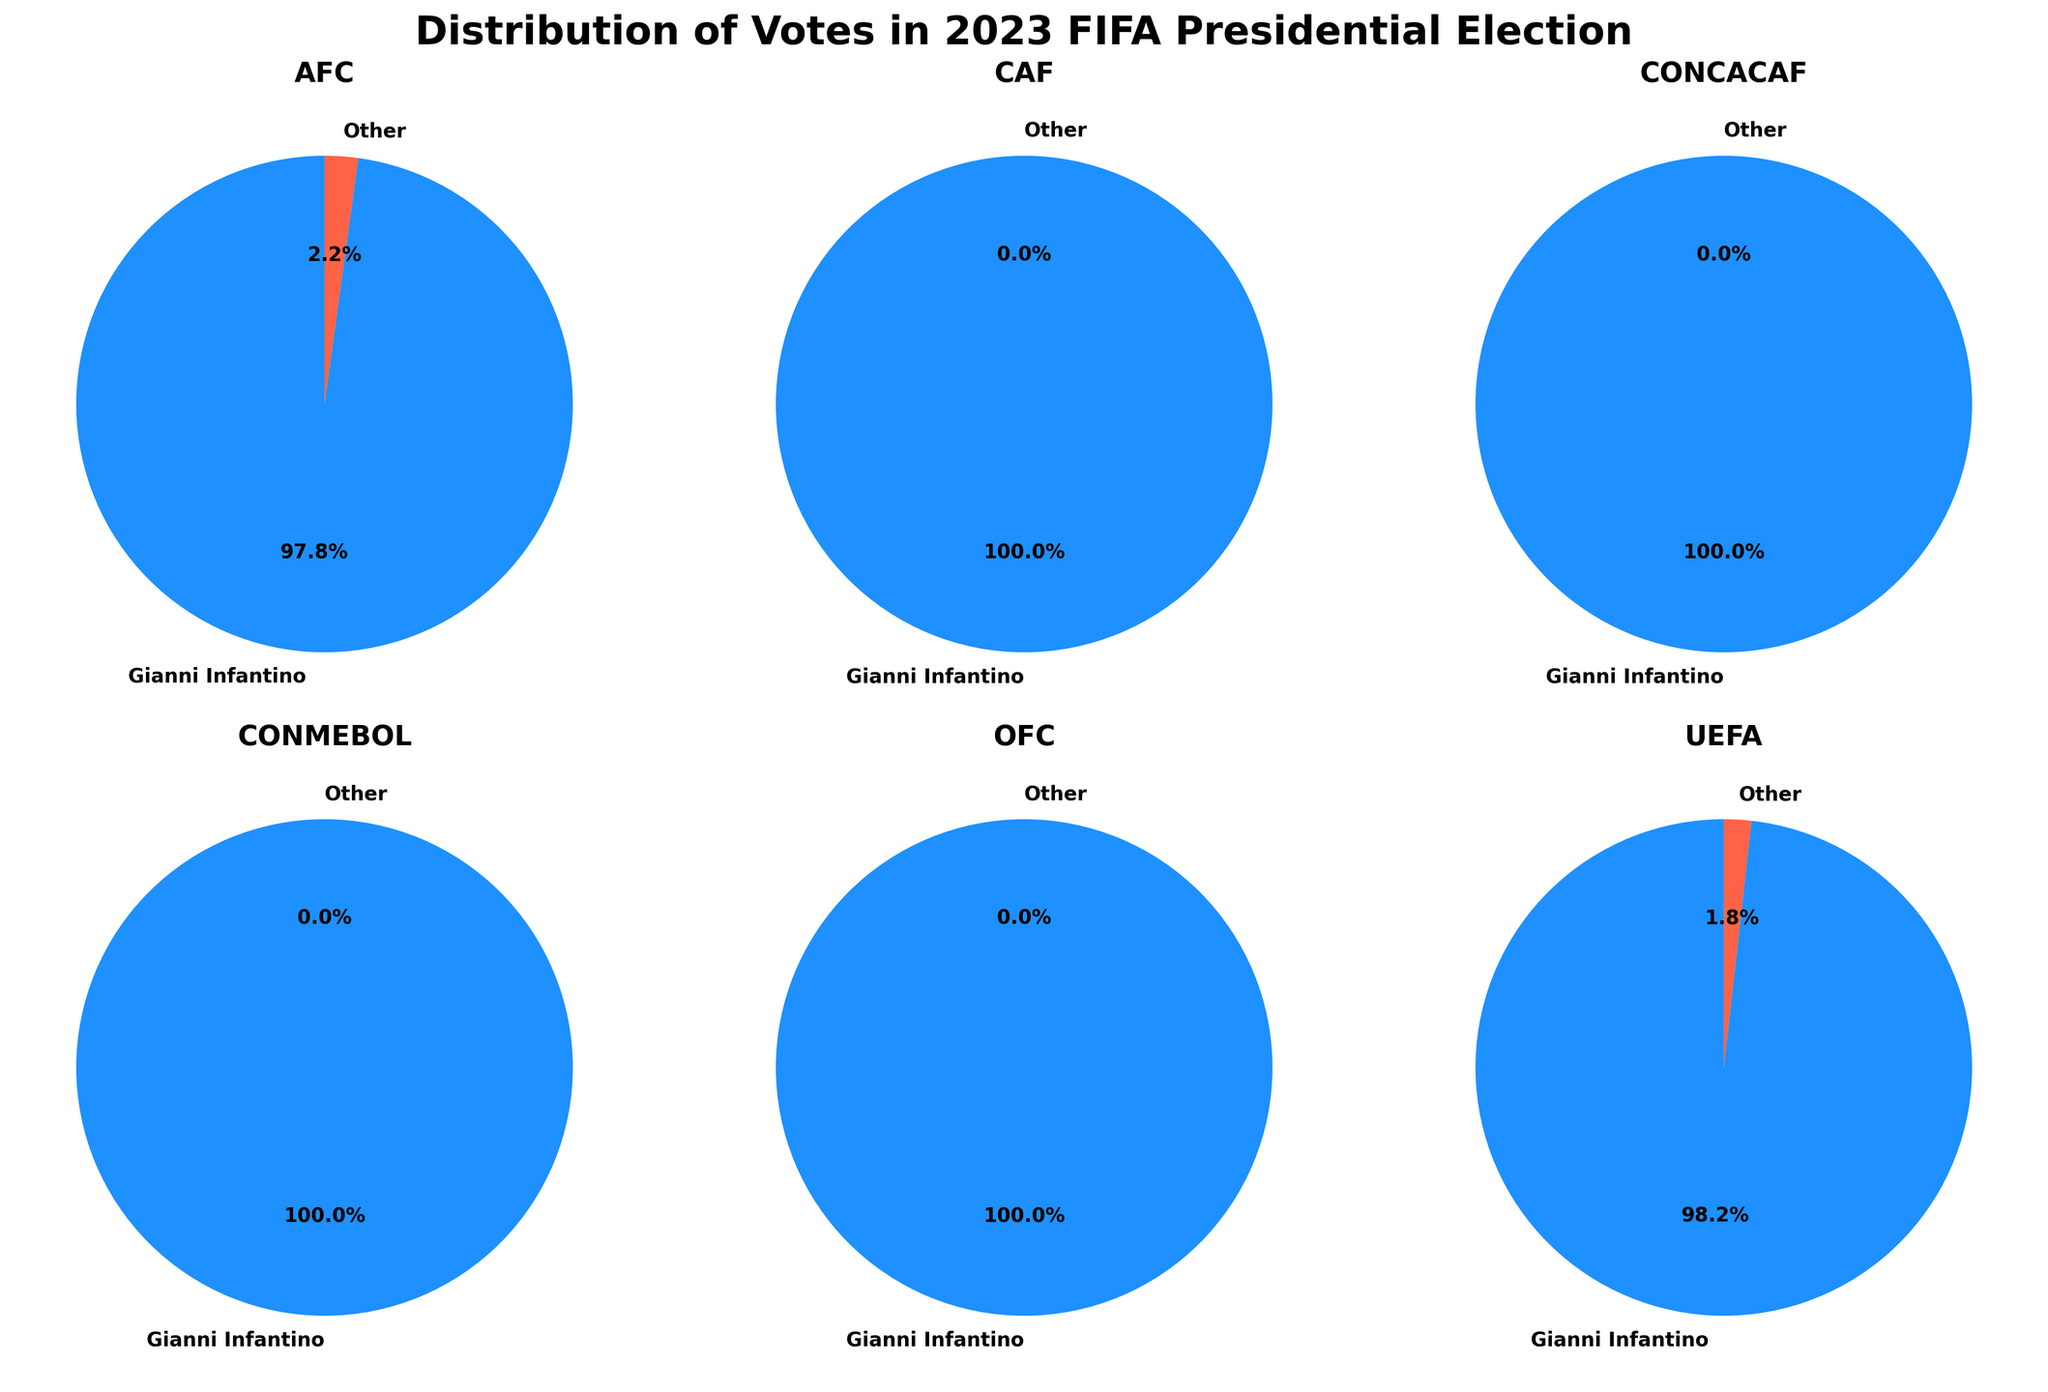Which confederation had the highest percentage of votes for candidates other than Gianni Infantino? By analyzing the pie charts, we see small segments representing votes for other candidates. Compare the percentages in these segments to find that AFC and UEFA each have a small portion for Other. AFC has 1 out of 46 total votes, and UEFA has 1 out of 56 total votes. The percentage for AFC is \( \frac{1}{46} \times 100 \approx 2.2\% \), and for UEFA it is \( \frac{1}{56} \times 100 \approx 1.8\% \). Therefore, AFC has the highest percentage for candidates other than Gianni Infantino.
Answer: AFC How many confederations had 100% of their votes for Gianni Infantino? By inspecting each pie chart, count the confederations where all votes are for Gianni Infantino. From the pie charts, CAF, CONCACAF, CONMEBOL, and OFC have only one segment, which indicates 100% of votes went to Gianni Infantino. Therefore, the number of confederations with 100% votes for Infantino is 4.
Answer: 4 Which confederation had the smallest total number of votes and how many votes were there? By looking at the total number of votes in each pie chart segment, find the confederation with the smallest value. CONMEBOL has the smallest total with 10 votes, as indicated in its respective pie chart.
Answer: CONMEBOL, 10 What is the total number of votes cast for Gianni Infantino across all confederations? To find the total votes for Gianni Infantino, sum up his votes from all the pie charts. The votes are AFC: 45, CAF: 54, CONCACAF: 35, CONMEBOL: 10, OFC: 11, UEFA: 55. Adding these together: 45 + 54 + 35 + 10 + 11 + 55 = 210.
Answer: 210 Which confederation had the highest number of votes for Gianni Infantino and how many votes were there? Observing each pie chart, compare the number of votes for Gianni Infantino. UEFA has the highest number with 55 votes, as indicated in its respective pie chart.
Answer: UEFA, 55 Calculate the average number of votes per confederation cast for candidates other than Gianni Infantino. First, identify the votes for candidates other than Gianni Infantino from each pie chart: AFC: 1, CAF: 0, CONCACAF: 0, CONMEBOL: 0, OFC: 0, UEFA: 1. Sum these values: 1 + 0 + 0 + 0 + 0 + 1 = 2. Now, divide by the number of confederations, which is 6: 2 / 6 = 0.33.
Answer: 0.33 